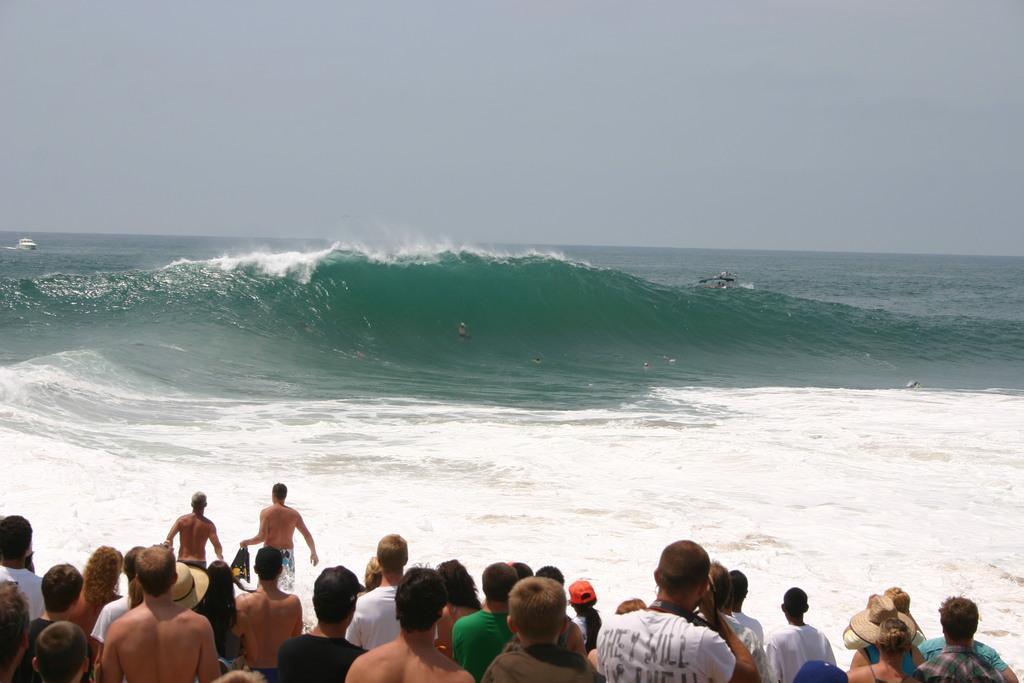How would you summarize this image in a sentence or two? In front of the image there are a few people, in front of them there are boats and a person in the sea. 